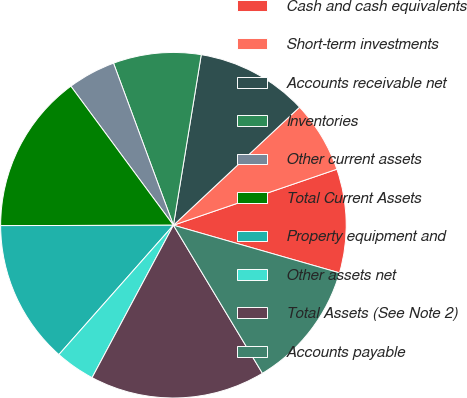<chart> <loc_0><loc_0><loc_500><loc_500><pie_chart><fcel>Cash and cash equivalents<fcel>Short-term investments<fcel>Accounts receivable net<fcel>Inventories<fcel>Other current assets<fcel>Total Current Assets<fcel>Property equipment and<fcel>Other assets net<fcel>Total Assets (See Note 2)<fcel>Accounts payable<nl><fcel>9.7%<fcel>6.72%<fcel>10.45%<fcel>8.21%<fcel>4.48%<fcel>14.92%<fcel>13.43%<fcel>3.73%<fcel>16.41%<fcel>11.94%<nl></chart> 